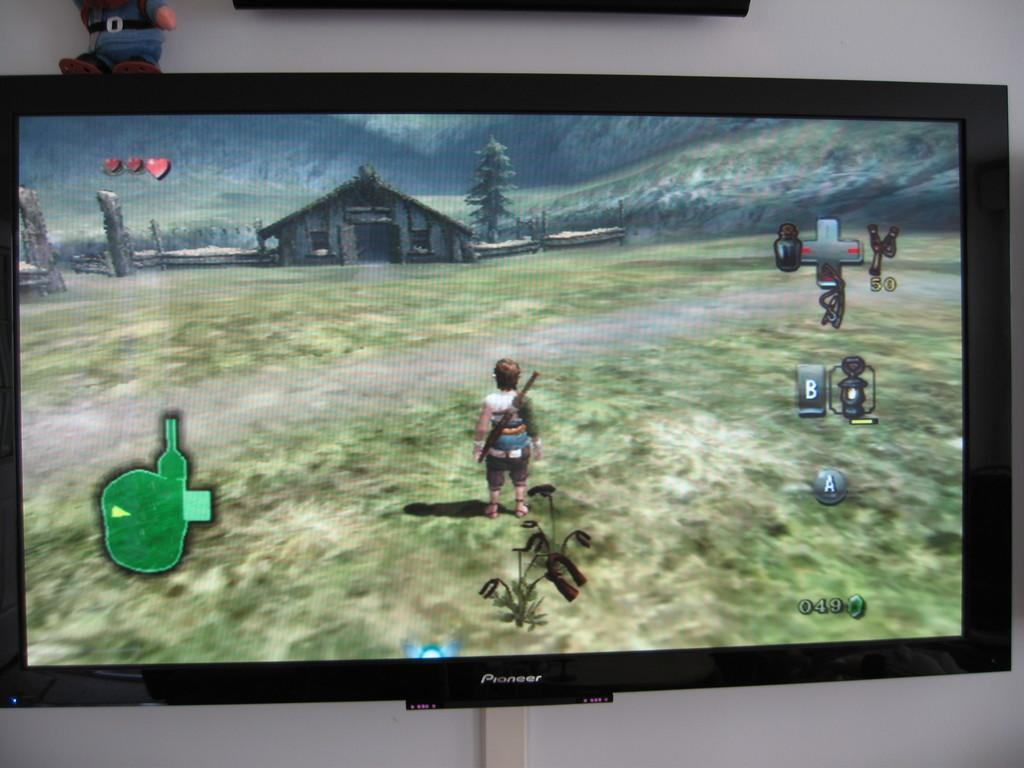<image>
Write a terse but informative summary of the picture. A flat screen made by Pioneer has a video game on the screen that shows a warrior in a field. 